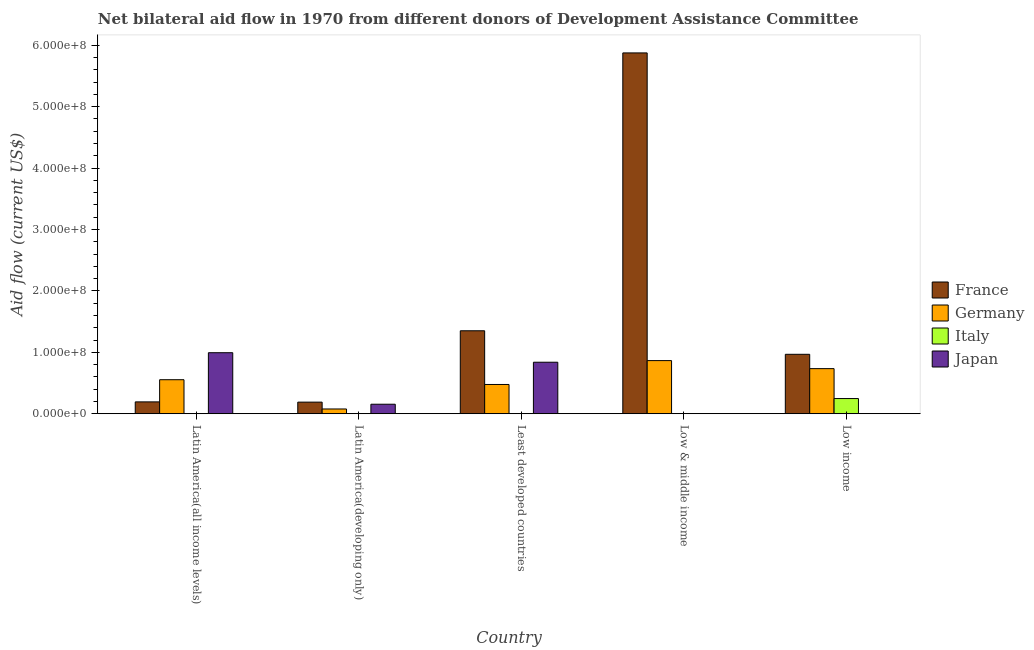How many different coloured bars are there?
Offer a very short reply. 4. Are the number of bars per tick equal to the number of legend labels?
Keep it short and to the point. No. Are the number of bars on each tick of the X-axis equal?
Offer a very short reply. No. How many bars are there on the 5th tick from the left?
Make the answer very short. 3. How many bars are there on the 3rd tick from the right?
Offer a very short reply. 3. What is the label of the 5th group of bars from the left?
Your response must be concise. Low income. What is the amount of aid given by germany in Low & middle income?
Provide a short and direct response. 8.65e+07. Across all countries, what is the maximum amount of aid given by japan?
Provide a succinct answer. 9.94e+07. Across all countries, what is the minimum amount of aid given by japan?
Give a very brief answer. 0. In which country was the amount of aid given by france maximum?
Your answer should be very brief. Low & middle income. What is the total amount of aid given by germany in the graph?
Keep it short and to the point. 2.71e+08. What is the difference between the amount of aid given by france in Latin America(developing only) and that in Least developed countries?
Make the answer very short. -1.16e+08. What is the difference between the amount of aid given by italy in Low & middle income and the amount of aid given by france in Least developed countries?
Your response must be concise. -1.35e+08. What is the average amount of aid given by japan per country?
Provide a succinct answer. 3.98e+07. What is the difference between the amount of aid given by germany and amount of aid given by japan in Latin America(developing only)?
Your response must be concise. -7.75e+06. What is the ratio of the amount of aid given by france in Latin America(developing only) to that in Low income?
Make the answer very short. 0.2. Is the difference between the amount of aid given by france in Latin America(developing only) and Least developed countries greater than the difference between the amount of aid given by japan in Latin America(developing only) and Least developed countries?
Ensure brevity in your answer.  No. What is the difference between the highest and the second highest amount of aid given by japan?
Your answer should be very brief. 1.55e+07. What is the difference between the highest and the lowest amount of aid given by japan?
Offer a terse response. 9.94e+07. In how many countries, is the amount of aid given by france greater than the average amount of aid given by france taken over all countries?
Your answer should be compact. 1. Is it the case that in every country, the sum of the amount of aid given by germany and amount of aid given by france is greater than the sum of amount of aid given by italy and amount of aid given by japan?
Provide a short and direct response. No. Is it the case that in every country, the sum of the amount of aid given by france and amount of aid given by germany is greater than the amount of aid given by italy?
Your answer should be very brief. Yes. Are all the bars in the graph horizontal?
Give a very brief answer. No. How many countries are there in the graph?
Offer a terse response. 5. Are the values on the major ticks of Y-axis written in scientific E-notation?
Provide a short and direct response. Yes. Does the graph contain any zero values?
Your response must be concise. Yes. Does the graph contain grids?
Offer a very short reply. No. How are the legend labels stacked?
Offer a terse response. Vertical. What is the title of the graph?
Provide a succinct answer. Net bilateral aid flow in 1970 from different donors of Development Assistance Committee. What is the label or title of the X-axis?
Make the answer very short. Country. What is the label or title of the Y-axis?
Make the answer very short. Aid flow (current US$). What is the Aid flow (current US$) in France in Latin America(all income levels)?
Your answer should be very brief. 1.93e+07. What is the Aid flow (current US$) in Germany in Latin America(all income levels)?
Offer a very short reply. 5.54e+07. What is the Aid flow (current US$) in Italy in Latin America(all income levels)?
Keep it short and to the point. 2.30e+05. What is the Aid flow (current US$) of Japan in Latin America(all income levels)?
Offer a very short reply. 9.94e+07. What is the Aid flow (current US$) of France in Latin America(developing only)?
Provide a succinct answer. 1.89e+07. What is the Aid flow (current US$) of Germany in Latin America(developing only)?
Your answer should be compact. 7.75e+06. What is the Aid flow (current US$) in Italy in Latin America(developing only)?
Your answer should be very brief. 0. What is the Aid flow (current US$) of Japan in Latin America(developing only)?
Offer a terse response. 1.55e+07. What is the Aid flow (current US$) in France in Least developed countries?
Provide a succinct answer. 1.35e+08. What is the Aid flow (current US$) in Germany in Least developed countries?
Keep it short and to the point. 4.77e+07. What is the Aid flow (current US$) of Italy in Least developed countries?
Offer a very short reply. 0. What is the Aid flow (current US$) of Japan in Least developed countries?
Provide a succinct answer. 8.39e+07. What is the Aid flow (current US$) of France in Low & middle income?
Your answer should be very brief. 5.88e+08. What is the Aid flow (current US$) in Germany in Low & middle income?
Make the answer very short. 8.65e+07. What is the Aid flow (current US$) of Japan in Low & middle income?
Your answer should be compact. 0. What is the Aid flow (current US$) of France in Low income?
Make the answer very short. 9.68e+07. What is the Aid flow (current US$) in Germany in Low income?
Provide a succinct answer. 7.35e+07. What is the Aid flow (current US$) of Italy in Low income?
Offer a very short reply. 2.47e+07. Across all countries, what is the maximum Aid flow (current US$) of France?
Give a very brief answer. 5.88e+08. Across all countries, what is the maximum Aid flow (current US$) in Germany?
Your answer should be compact. 8.65e+07. Across all countries, what is the maximum Aid flow (current US$) in Italy?
Keep it short and to the point. 2.47e+07. Across all countries, what is the maximum Aid flow (current US$) of Japan?
Offer a very short reply. 9.94e+07. Across all countries, what is the minimum Aid flow (current US$) in France?
Keep it short and to the point. 1.89e+07. Across all countries, what is the minimum Aid flow (current US$) of Germany?
Keep it short and to the point. 7.75e+06. Across all countries, what is the minimum Aid flow (current US$) of Italy?
Offer a very short reply. 0. Across all countries, what is the minimum Aid flow (current US$) in Japan?
Offer a very short reply. 0. What is the total Aid flow (current US$) of France in the graph?
Offer a very short reply. 8.58e+08. What is the total Aid flow (current US$) in Germany in the graph?
Make the answer very short. 2.71e+08. What is the total Aid flow (current US$) of Italy in the graph?
Offer a terse response. 2.50e+07. What is the total Aid flow (current US$) of Japan in the graph?
Give a very brief answer. 1.99e+08. What is the difference between the Aid flow (current US$) in France in Latin America(all income levels) and that in Latin America(developing only)?
Ensure brevity in your answer.  4.00e+05. What is the difference between the Aid flow (current US$) in Germany in Latin America(all income levels) and that in Latin America(developing only)?
Keep it short and to the point. 4.77e+07. What is the difference between the Aid flow (current US$) of Japan in Latin America(all income levels) and that in Latin America(developing only)?
Your answer should be very brief. 8.39e+07. What is the difference between the Aid flow (current US$) of France in Latin America(all income levels) and that in Least developed countries?
Offer a terse response. -1.16e+08. What is the difference between the Aid flow (current US$) in Germany in Latin America(all income levels) and that in Least developed countries?
Your answer should be very brief. 7.75e+06. What is the difference between the Aid flow (current US$) of Japan in Latin America(all income levels) and that in Least developed countries?
Provide a short and direct response. 1.55e+07. What is the difference between the Aid flow (current US$) in France in Latin America(all income levels) and that in Low & middle income?
Your answer should be compact. -5.68e+08. What is the difference between the Aid flow (current US$) of Germany in Latin America(all income levels) and that in Low & middle income?
Keep it short and to the point. -3.11e+07. What is the difference between the Aid flow (current US$) in France in Latin America(all income levels) and that in Low income?
Offer a terse response. -7.75e+07. What is the difference between the Aid flow (current US$) of Germany in Latin America(all income levels) and that in Low income?
Provide a short and direct response. -1.80e+07. What is the difference between the Aid flow (current US$) of Italy in Latin America(all income levels) and that in Low income?
Give a very brief answer. -2.45e+07. What is the difference between the Aid flow (current US$) in France in Latin America(developing only) and that in Least developed countries?
Give a very brief answer. -1.16e+08. What is the difference between the Aid flow (current US$) of Germany in Latin America(developing only) and that in Least developed countries?
Make the answer very short. -3.99e+07. What is the difference between the Aid flow (current US$) in Japan in Latin America(developing only) and that in Least developed countries?
Your response must be concise. -6.84e+07. What is the difference between the Aid flow (current US$) of France in Latin America(developing only) and that in Low & middle income?
Provide a short and direct response. -5.69e+08. What is the difference between the Aid flow (current US$) of Germany in Latin America(developing only) and that in Low & middle income?
Your response must be concise. -7.88e+07. What is the difference between the Aid flow (current US$) of France in Latin America(developing only) and that in Low income?
Your answer should be compact. -7.79e+07. What is the difference between the Aid flow (current US$) in Germany in Latin America(developing only) and that in Low income?
Make the answer very short. -6.57e+07. What is the difference between the Aid flow (current US$) in France in Least developed countries and that in Low & middle income?
Offer a very short reply. -4.52e+08. What is the difference between the Aid flow (current US$) in Germany in Least developed countries and that in Low & middle income?
Offer a terse response. -3.89e+07. What is the difference between the Aid flow (current US$) in France in Least developed countries and that in Low income?
Provide a short and direct response. 3.83e+07. What is the difference between the Aid flow (current US$) of Germany in Least developed countries and that in Low income?
Provide a succinct answer. -2.58e+07. What is the difference between the Aid flow (current US$) of France in Low & middle income and that in Low income?
Provide a short and direct response. 4.91e+08. What is the difference between the Aid flow (current US$) in Germany in Low & middle income and that in Low income?
Offer a terse response. 1.31e+07. What is the difference between the Aid flow (current US$) of France in Latin America(all income levels) and the Aid flow (current US$) of Germany in Latin America(developing only)?
Ensure brevity in your answer.  1.16e+07. What is the difference between the Aid flow (current US$) of France in Latin America(all income levels) and the Aid flow (current US$) of Japan in Latin America(developing only)?
Offer a very short reply. 3.80e+06. What is the difference between the Aid flow (current US$) in Germany in Latin America(all income levels) and the Aid flow (current US$) in Japan in Latin America(developing only)?
Provide a succinct answer. 3.99e+07. What is the difference between the Aid flow (current US$) in Italy in Latin America(all income levels) and the Aid flow (current US$) in Japan in Latin America(developing only)?
Offer a very short reply. -1.53e+07. What is the difference between the Aid flow (current US$) of France in Latin America(all income levels) and the Aid flow (current US$) of Germany in Least developed countries?
Offer a terse response. -2.84e+07. What is the difference between the Aid flow (current US$) in France in Latin America(all income levels) and the Aid flow (current US$) in Japan in Least developed countries?
Offer a very short reply. -6.46e+07. What is the difference between the Aid flow (current US$) of Germany in Latin America(all income levels) and the Aid flow (current US$) of Japan in Least developed countries?
Ensure brevity in your answer.  -2.85e+07. What is the difference between the Aid flow (current US$) in Italy in Latin America(all income levels) and the Aid flow (current US$) in Japan in Least developed countries?
Offer a terse response. -8.37e+07. What is the difference between the Aid flow (current US$) of France in Latin America(all income levels) and the Aid flow (current US$) of Germany in Low & middle income?
Make the answer very short. -6.72e+07. What is the difference between the Aid flow (current US$) of France in Latin America(all income levels) and the Aid flow (current US$) of Germany in Low income?
Make the answer very short. -5.42e+07. What is the difference between the Aid flow (current US$) of France in Latin America(all income levels) and the Aid flow (current US$) of Italy in Low income?
Offer a terse response. -5.43e+06. What is the difference between the Aid flow (current US$) of Germany in Latin America(all income levels) and the Aid flow (current US$) of Italy in Low income?
Offer a very short reply. 3.07e+07. What is the difference between the Aid flow (current US$) of France in Latin America(developing only) and the Aid flow (current US$) of Germany in Least developed countries?
Your answer should be very brief. -2.88e+07. What is the difference between the Aid flow (current US$) in France in Latin America(developing only) and the Aid flow (current US$) in Japan in Least developed countries?
Your answer should be very brief. -6.50e+07. What is the difference between the Aid flow (current US$) of Germany in Latin America(developing only) and the Aid flow (current US$) of Japan in Least developed countries?
Offer a very short reply. -7.61e+07. What is the difference between the Aid flow (current US$) in France in Latin America(developing only) and the Aid flow (current US$) in Germany in Low & middle income?
Provide a short and direct response. -6.76e+07. What is the difference between the Aid flow (current US$) of France in Latin America(developing only) and the Aid flow (current US$) of Germany in Low income?
Keep it short and to the point. -5.46e+07. What is the difference between the Aid flow (current US$) of France in Latin America(developing only) and the Aid flow (current US$) of Italy in Low income?
Your answer should be compact. -5.83e+06. What is the difference between the Aid flow (current US$) of Germany in Latin America(developing only) and the Aid flow (current US$) of Italy in Low income?
Make the answer very short. -1.70e+07. What is the difference between the Aid flow (current US$) in France in Least developed countries and the Aid flow (current US$) in Germany in Low & middle income?
Make the answer very short. 4.86e+07. What is the difference between the Aid flow (current US$) in France in Least developed countries and the Aid flow (current US$) in Germany in Low income?
Provide a succinct answer. 6.16e+07. What is the difference between the Aid flow (current US$) in France in Least developed countries and the Aid flow (current US$) in Italy in Low income?
Provide a succinct answer. 1.10e+08. What is the difference between the Aid flow (current US$) of Germany in Least developed countries and the Aid flow (current US$) of Italy in Low income?
Ensure brevity in your answer.  2.29e+07. What is the difference between the Aid flow (current US$) of France in Low & middle income and the Aid flow (current US$) of Germany in Low income?
Offer a terse response. 5.14e+08. What is the difference between the Aid flow (current US$) in France in Low & middle income and the Aid flow (current US$) in Italy in Low income?
Offer a terse response. 5.63e+08. What is the difference between the Aid flow (current US$) of Germany in Low & middle income and the Aid flow (current US$) of Italy in Low income?
Make the answer very short. 6.18e+07. What is the average Aid flow (current US$) of France per country?
Keep it short and to the point. 1.72e+08. What is the average Aid flow (current US$) in Germany per country?
Your answer should be compact. 5.42e+07. What is the average Aid flow (current US$) in Italy per country?
Keep it short and to the point. 4.99e+06. What is the average Aid flow (current US$) of Japan per country?
Offer a terse response. 3.98e+07. What is the difference between the Aid flow (current US$) in France and Aid flow (current US$) in Germany in Latin America(all income levels)?
Provide a short and direct response. -3.61e+07. What is the difference between the Aid flow (current US$) of France and Aid flow (current US$) of Italy in Latin America(all income levels)?
Your answer should be very brief. 1.91e+07. What is the difference between the Aid flow (current US$) of France and Aid flow (current US$) of Japan in Latin America(all income levels)?
Your answer should be very brief. -8.01e+07. What is the difference between the Aid flow (current US$) of Germany and Aid flow (current US$) of Italy in Latin America(all income levels)?
Ensure brevity in your answer.  5.52e+07. What is the difference between the Aid flow (current US$) in Germany and Aid flow (current US$) in Japan in Latin America(all income levels)?
Keep it short and to the point. -4.40e+07. What is the difference between the Aid flow (current US$) in Italy and Aid flow (current US$) in Japan in Latin America(all income levels)?
Your answer should be very brief. -9.92e+07. What is the difference between the Aid flow (current US$) of France and Aid flow (current US$) of Germany in Latin America(developing only)?
Offer a very short reply. 1.12e+07. What is the difference between the Aid flow (current US$) in France and Aid flow (current US$) in Japan in Latin America(developing only)?
Keep it short and to the point. 3.40e+06. What is the difference between the Aid flow (current US$) of Germany and Aid flow (current US$) of Japan in Latin America(developing only)?
Provide a succinct answer. -7.75e+06. What is the difference between the Aid flow (current US$) in France and Aid flow (current US$) in Germany in Least developed countries?
Your answer should be compact. 8.74e+07. What is the difference between the Aid flow (current US$) in France and Aid flow (current US$) in Japan in Least developed countries?
Your answer should be compact. 5.12e+07. What is the difference between the Aid flow (current US$) in Germany and Aid flow (current US$) in Japan in Least developed countries?
Provide a succinct answer. -3.62e+07. What is the difference between the Aid flow (current US$) of France and Aid flow (current US$) of Germany in Low & middle income?
Provide a succinct answer. 5.01e+08. What is the difference between the Aid flow (current US$) of France and Aid flow (current US$) of Germany in Low income?
Provide a succinct answer. 2.33e+07. What is the difference between the Aid flow (current US$) of France and Aid flow (current US$) of Italy in Low income?
Provide a short and direct response. 7.21e+07. What is the difference between the Aid flow (current US$) in Germany and Aid flow (current US$) in Italy in Low income?
Provide a short and direct response. 4.87e+07. What is the ratio of the Aid flow (current US$) in France in Latin America(all income levels) to that in Latin America(developing only)?
Your answer should be compact. 1.02. What is the ratio of the Aid flow (current US$) in Germany in Latin America(all income levels) to that in Latin America(developing only)?
Offer a very short reply. 7.15. What is the ratio of the Aid flow (current US$) of Japan in Latin America(all income levels) to that in Latin America(developing only)?
Offer a very short reply. 6.41. What is the ratio of the Aid flow (current US$) in France in Latin America(all income levels) to that in Least developed countries?
Keep it short and to the point. 0.14. What is the ratio of the Aid flow (current US$) in Germany in Latin America(all income levels) to that in Least developed countries?
Make the answer very short. 1.16. What is the ratio of the Aid flow (current US$) of Japan in Latin America(all income levels) to that in Least developed countries?
Offer a terse response. 1.18. What is the ratio of the Aid flow (current US$) of France in Latin America(all income levels) to that in Low & middle income?
Ensure brevity in your answer.  0.03. What is the ratio of the Aid flow (current US$) of Germany in Latin America(all income levels) to that in Low & middle income?
Offer a very short reply. 0.64. What is the ratio of the Aid flow (current US$) in France in Latin America(all income levels) to that in Low income?
Your answer should be very brief. 0.2. What is the ratio of the Aid flow (current US$) of Germany in Latin America(all income levels) to that in Low income?
Your answer should be compact. 0.75. What is the ratio of the Aid flow (current US$) of Italy in Latin America(all income levels) to that in Low income?
Offer a very short reply. 0.01. What is the ratio of the Aid flow (current US$) of France in Latin America(developing only) to that in Least developed countries?
Your answer should be compact. 0.14. What is the ratio of the Aid flow (current US$) of Germany in Latin America(developing only) to that in Least developed countries?
Your answer should be compact. 0.16. What is the ratio of the Aid flow (current US$) in Japan in Latin America(developing only) to that in Least developed countries?
Your answer should be very brief. 0.18. What is the ratio of the Aid flow (current US$) in France in Latin America(developing only) to that in Low & middle income?
Provide a short and direct response. 0.03. What is the ratio of the Aid flow (current US$) of Germany in Latin America(developing only) to that in Low & middle income?
Your answer should be very brief. 0.09. What is the ratio of the Aid flow (current US$) of France in Latin America(developing only) to that in Low income?
Give a very brief answer. 0.2. What is the ratio of the Aid flow (current US$) in Germany in Latin America(developing only) to that in Low income?
Give a very brief answer. 0.11. What is the ratio of the Aid flow (current US$) in France in Least developed countries to that in Low & middle income?
Make the answer very short. 0.23. What is the ratio of the Aid flow (current US$) in Germany in Least developed countries to that in Low & middle income?
Make the answer very short. 0.55. What is the ratio of the Aid flow (current US$) in France in Least developed countries to that in Low income?
Keep it short and to the point. 1.4. What is the ratio of the Aid flow (current US$) in Germany in Least developed countries to that in Low income?
Ensure brevity in your answer.  0.65. What is the ratio of the Aid flow (current US$) of France in Low & middle income to that in Low income?
Offer a terse response. 6.07. What is the ratio of the Aid flow (current US$) of Germany in Low & middle income to that in Low income?
Give a very brief answer. 1.18. What is the difference between the highest and the second highest Aid flow (current US$) in France?
Make the answer very short. 4.52e+08. What is the difference between the highest and the second highest Aid flow (current US$) of Germany?
Your answer should be very brief. 1.31e+07. What is the difference between the highest and the second highest Aid flow (current US$) in Japan?
Ensure brevity in your answer.  1.55e+07. What is the difference between the highest and the lowest Aid flow (current US$) in France?
Offer a very short reply. 5.69e+08. What is the difference between the highest and the lowest Aid flow (current US$) of Germany?
Ensure brevity in your answer.  7.88e+07. What is the difference between the highest and the lowest Aid flow (current US$) in Italy?
Keep it short and to the point. 2.47e+07. What is the difference between the highest and the lowest Aid flow (current US$) in Japan?
Your answer should be very brief. 9.94e+07. 